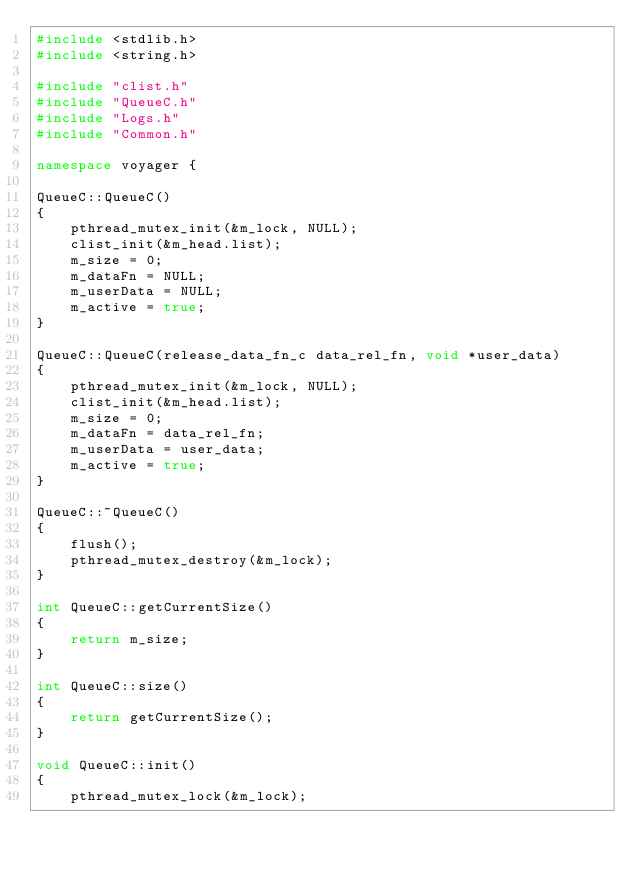Convert code to text. <code><loc_0><loc_0><loc_500><loc_500><_C++_>#include <stdlib.h>
#include <string.h>

#include "clist.h"
#include "QueueC.h"
#include "Logs.h"
#include "Common.h"

namespace voyager {

QueueC::QueueC()
{
    pthread_mutex_init(&m_lock, NULL);
    clist_init(&m_head.list);
    m_size = 0;
    m_dataFn = NULL;
    m_userData = NULL;
    m_active = true;
}

QueueC::QueueC(release_data_fn_c data_rel_fn, void *user_data)
{
    pthread_mutex_init(&m_lock, NULL);
    clist_init(&m_head.list);
    m_size = 0;
    m_dataFn = data_rel_fn;
    m_userData = user_data;
    m_active = true;
}

QueueC::~QueueC()
{
    flush();
    pthread_mutex_destroy(&m_lock);
}

int QueueC::getCurrentSize()
{
    return m_size;
}

int QueueC::size()
{
    return getCurrentSize();
}

void QueueC::init()
{
    pthread_mutex_lock(&m_lock);</code> 